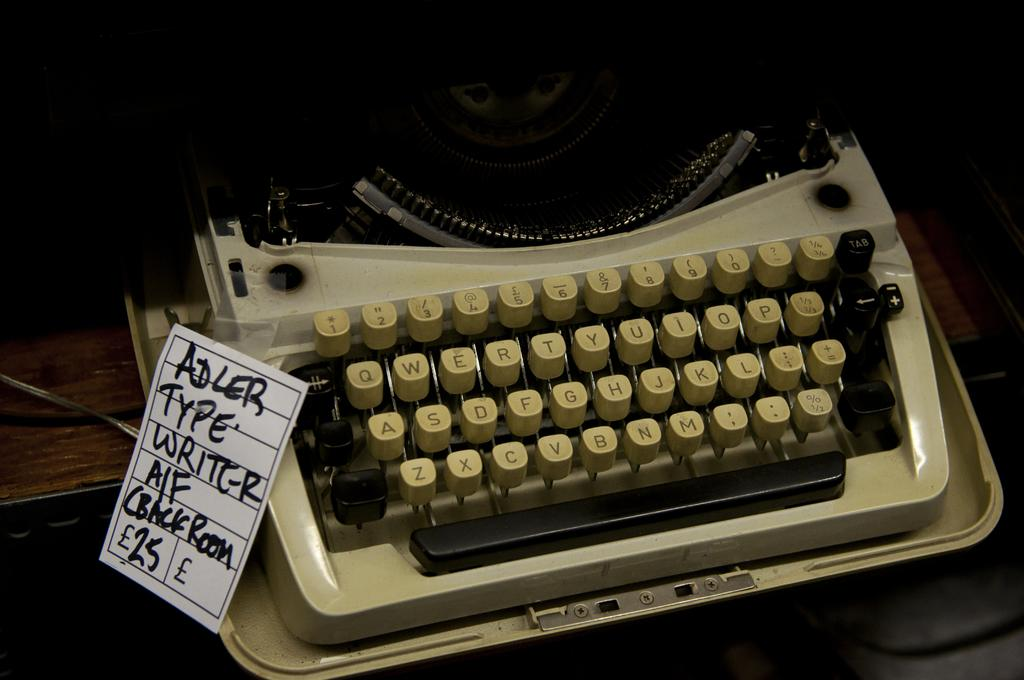<image>
Summarize the visual content of the image. On display is an old fashioned Adler type writer with a price tag on it for £25. 